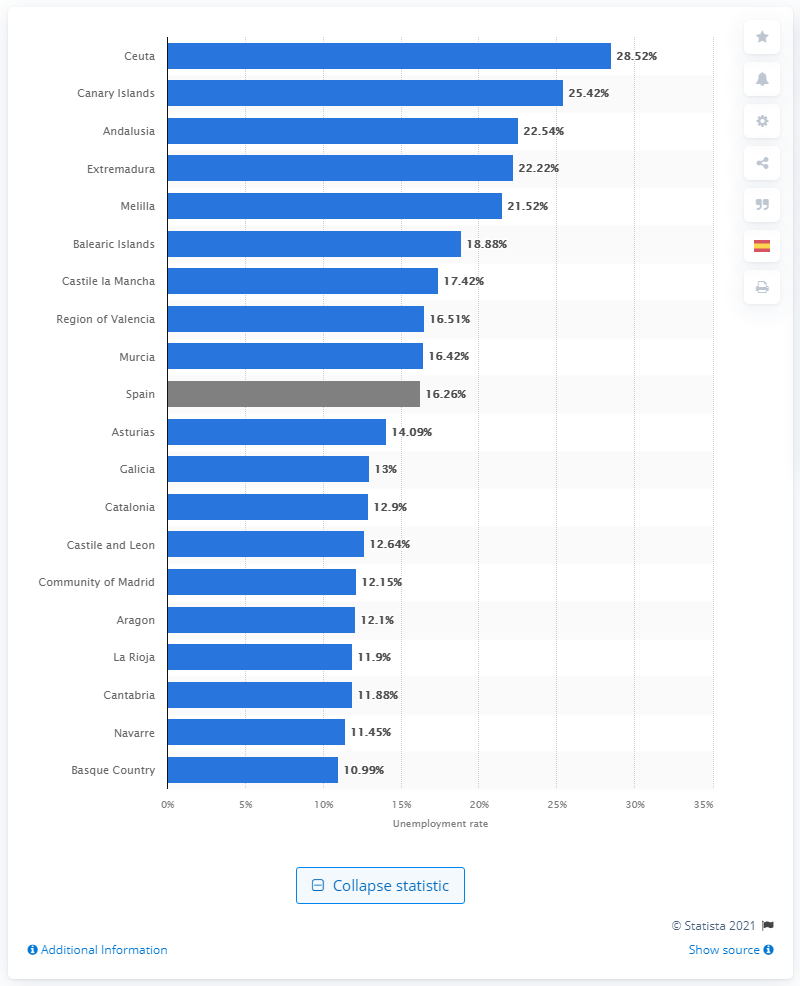Point out several critical features in this image. Extremadura, the southern region bordering Portugal, has a name. In Ceuta, the unemployment rate was 28.52%. According to official data, in the first quarter of 2021, Spain's highest unemployment rate was observed in the autonomous city of Ceuta. The average unemployment rate in Navarre was 10.99. 